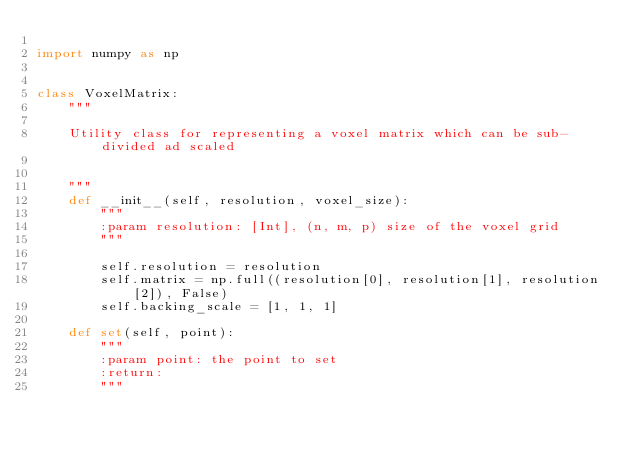<code> <loc_0><loc_0><loc_500><loc_500><_Python_>
import numpy as np


class VoxelMatrix:
    """

    Utility class for representing a voxel matrix which can be sub-divided ad scaled


    """
    def __init__(self, resolution, voxel_size):
        """
        :param resolution: [Int], (n, m, p) size of the voxel grid
        """

        self.resolution = resolution
        self.matrix = np.full((resolution[0], resolution[1], resolution[2]), False)
        self.backing_scale = [1, 1, 1]

    def set(self, point):
        """
        :param point: the point to set
        :return:
        """
</code> 